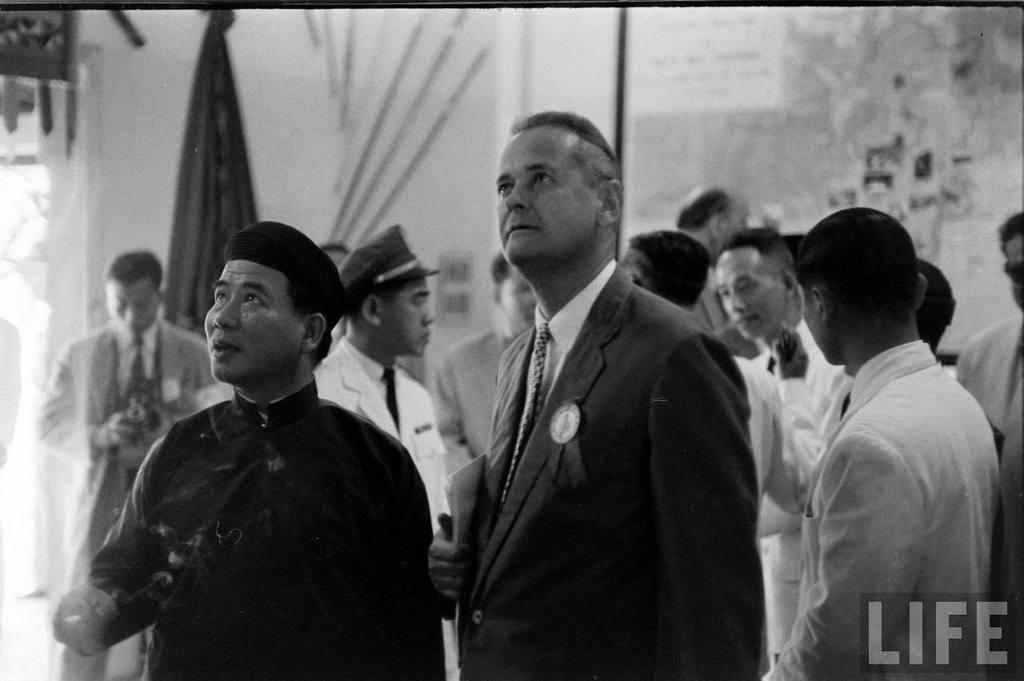Could you give a brief overview of what you see in this image? This is a black and white picture, in this image we can see a group of people standing, among them some people are holding the objects, in the background it looks like a screen with images, at the bottom of the image we can see the text. 